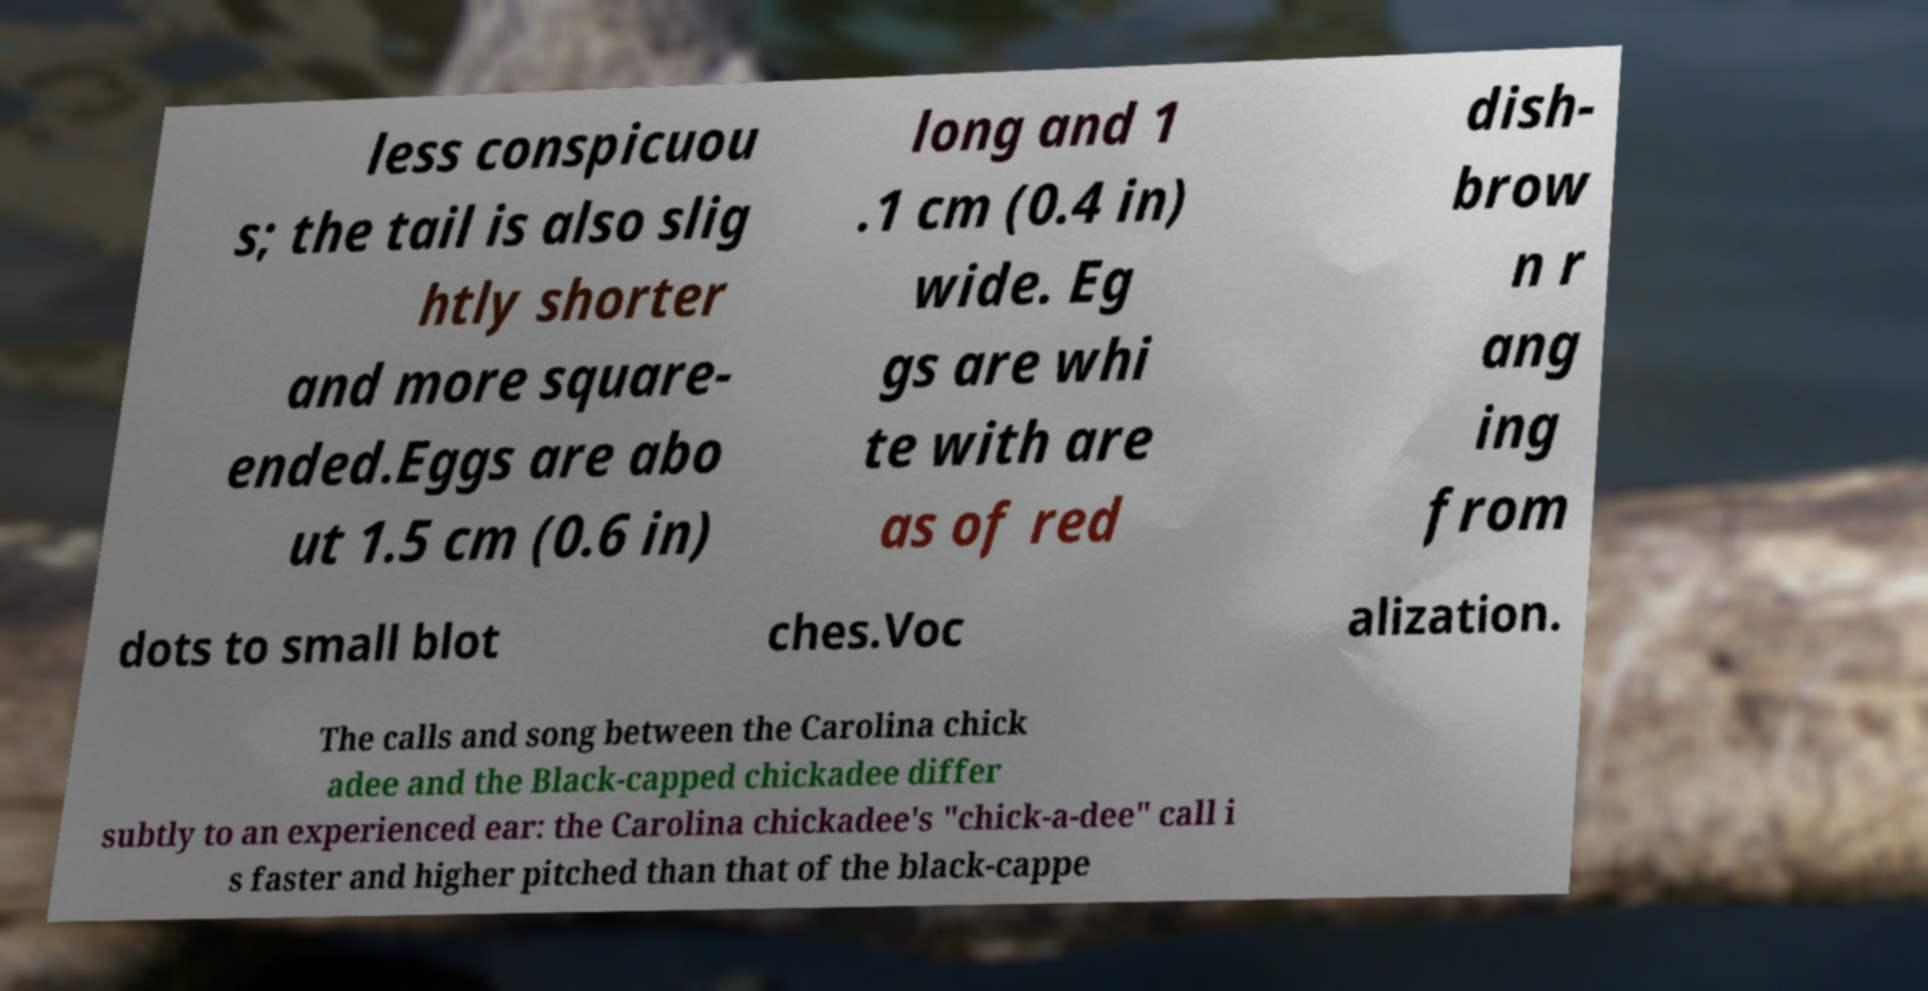Please read and relay the text visible in this image. What does it say? less conspicuou s; the tail is also slig htly shorter and more square- ended.Eggs are abo ut 1.5 cm (0.6 in) long and 1 .1 cm (0.4 in) wide. Eg gs are whi te with are as of red dish- brow n r ang ing from dots to small blot ches.Voc alization. The calls and song between the Carolina chick adee and the Black-capped chickadee differ subtly to an experienced ear: the Carolina chickadee's "chick-a-dee" call i s faster and higher pitched than that of the black-cappe 